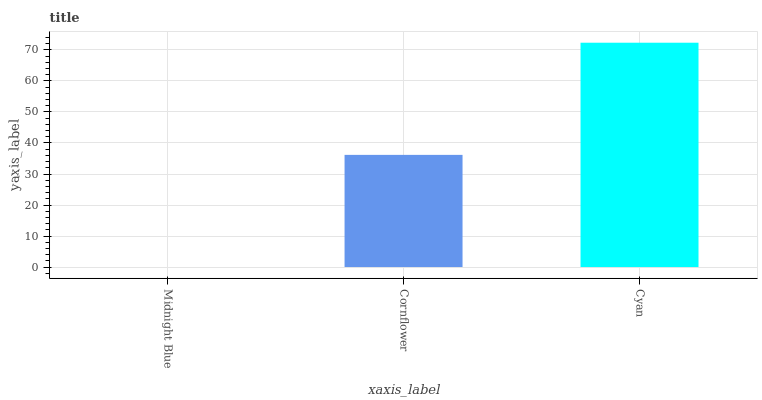Is Midnight Blue the minimum?
Answer yes or no. Yes. Is Cyan the maximum?
Answer yes or no. Yes. Is Cornflower the minimum?
Answer yes or no. No. Is Cornflower the maximum?
Answer yes or no. No. Is Cornflower greater than Midnight Blue?
Answer yes or no. Yes. Is Midnight Blue less than Cornflower?
Answer yes or no. Yes. Is Midnight Blue greater than Cornflower?
Answer yes or no. No. Is Cornflower less than Midnight Blue?
Answer yes or no. No. Is Cornflower the high median?
Answer yes or no. Yes. Is Cornflower the low median?
Answer yes or no. Yes. Is Cyan the high median?
Answer yes or no. No. Is Midnight Blue the low median?
Answer yes or no. No. 